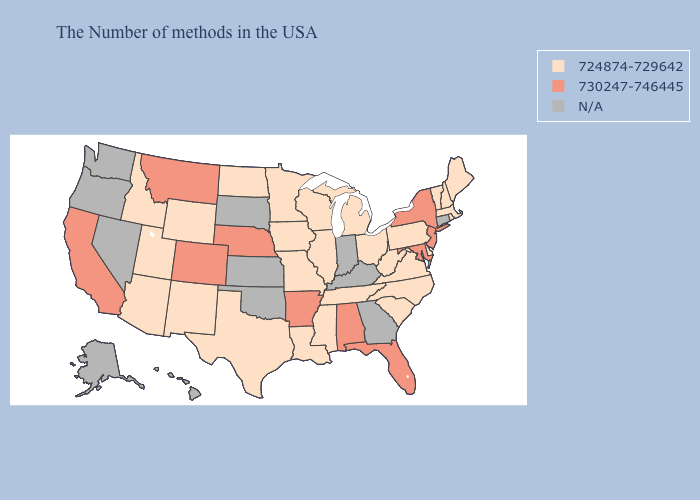Name the states that have a value in the range 724874-729642?
Answer briefly. Maine, Massachusetts, Rhode Island, New Hampshire, Vermont, Delaware, Pennsylvania, Virginia, North Carolina, South Carolina, West Virginia, Ohio, Michigan, Tennessee, Wisconsin, Illinois, Mississippi, Louisiana, Missouri, Minnesota, Iowa, Texas, North Dakota, Wyoming, New Mexico, Utah, Arizona, Idaho. What is the lowest value in states that border Idaho?
Answer briefly. 724874-729642. What is the highest value in the USA?
Write a very short answer. 730247-746445. Does the first symbol in the legend represent the smallest category?
Keep it brief. Yes. Name the states that have a value in the range 724874-729642?
Give a very brief answer. Maine, Massachusetts, Rhode Island, New Hampshire, Vermont, Delaware, Pennsylvania, Virginia, North Carolina, South Carolina, West Virginia, Ohio, Michigan, Tennessee, Wisconsin, Illinois, Mississippi, Louisiana, Missouri, Minnesota, Iowa, Texas, North Dakota, Wyoming, New Mexico, Utah, Arizona, Idaho. Which states hav the highest value in the West?
Answer briefly. Colorado, Montana, California. Which states have the lowest value in the USA?
Short answer required. Maine, Massachusetts, Rhode Island, New Hampshire, Vermont, Delaware, Pennsylvania, Virginia, North Carolina, South Carolina, West Virginia, Ohio, Michigan, Tennessee, Wisconsin, Illinois, Mississippi, Louisiana, Missouri, Minnesota, Iowa, Texas, North Dakota, Wyoming, New Mexico, Utah, Arizona, Idaho. Does the first symbol in the legend represent the smallest category?
Write a very short answer. Yes. Does the map have missing data?
Give a very brief answer. Yes. What is the highest value in the USA?
Concise answer only. 730247-746445. What is the value of Massachusetts?
Give a very brief answer. 724874-729642. Does North Dakota have the highest value in the MidWest?
Answer briefly. No. Does North Dakota have the highest value in the USA?
Write a very short answer. No. 